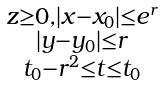<formula> <loc_0><loc_0><loc_500><loc_500>\begin{smallmatrix} z \geq 0 , | x - x _ { 0 } | \leq e ^ { r } \\ | y - y _ { 0 } | \leq r \\ t _ { 0 } - r ^ { 2 } \leq t \leq t _ { 0 } \end{smallmatrix}</formula> 